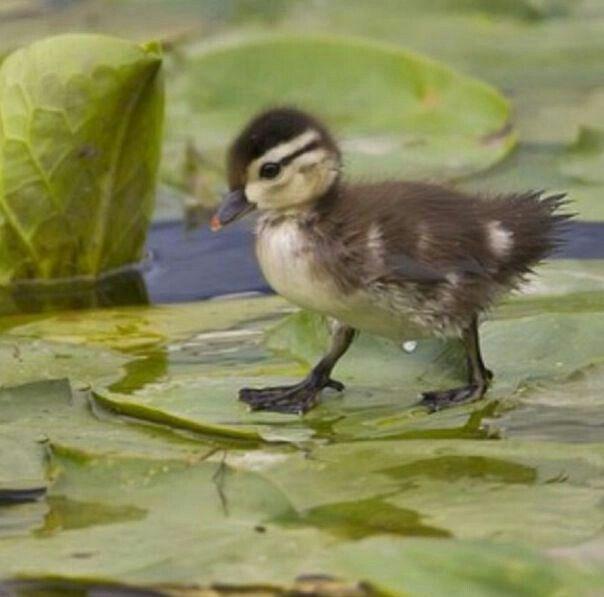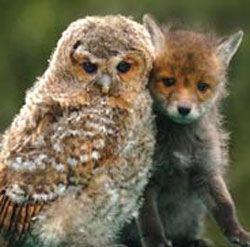The first image is the image on the left, the second image is the image on the right. Considering the images on both sides, is "Each animal in one of the images is a different species." valid? Answer yes or no. Yes. The first image is the image on the left, the second image is the image on the right. For the images displayed, is the sentence "There is at least two primates in the left image." factually correct? Answer yes or no. No. 